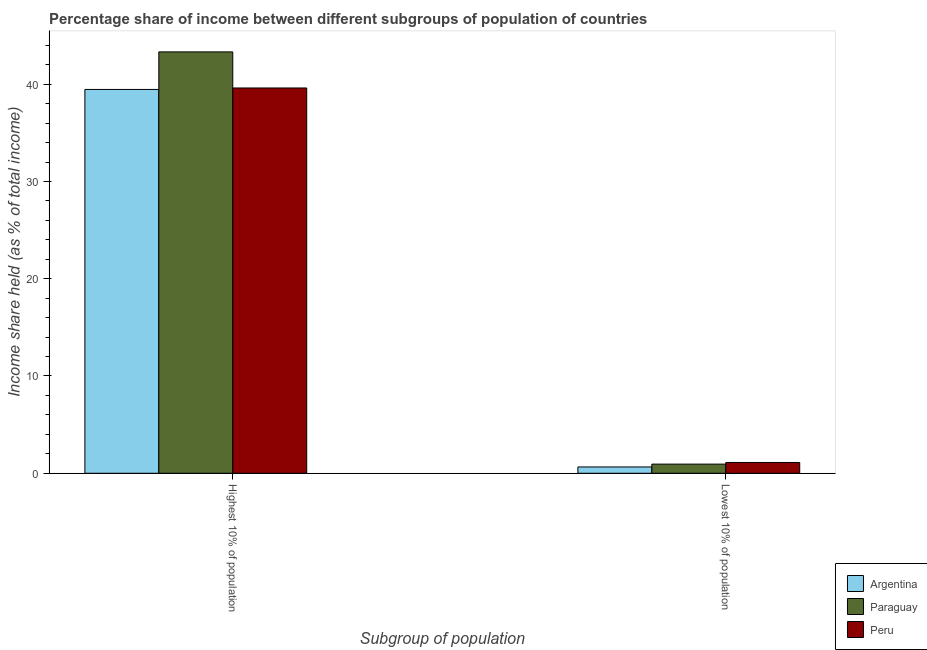How many different coloured bars are there?
Offer a very short reply. 3. How many bars are there on the 2nd tick from the left?
Your response must be concise. 3. How many bars are there on the 2nd tick from the right?
Ensure brevity in your answer.  3. What is the label of the 2nd group of bars from the left?
Provide a short and direct response. Lowest 10% of population. What is the income share held by highest 10% of the population in Argentina?
Your answer should be very brief. 39.46. Across all countries, what is the maximum income share held by highest 10% of the population?
Your answer should be very brief. 43.32. Across all countries, what is the minimum income share held by lowest 10% of the population?
Keep it short and to the point. 0.65. In which country was the income share held by highest 10% of the population minimum?
Ensure brevity in your answer.  Argentina. What is the total income share held by highest 10% of the population in the graph?
Make the answer very short. 122.39. What is the difference between the income share held by lowest 10% of the population in Peru and that in Argentina?
Give a very brief answer. 0.46. What is the difference between the income share held by lowest 10% of the population in Peru and the income share held by highest 10% of the population in Argentina?
Offer a very short reply. -38.35. What is the average income share held by highest 10% of the population per country?
Your answer should be compact. 40.8. What is the difference between the income share held by lowest 10% of the population and income share held by highest 10% of the population in Argentina?
Your response must be concise. -38.81. What is the ratio of the income share held by lowest 10% of the population in Paraguay to that in Argentina?
Offer a very short reply. 1.45. Is the income share held by lowest 10% of the population in Peru less than that in Paraguay?
Your response must be concise. No. What does the 2nd bar from the left in Highest 10% of population represents?
Give a very brief answer. Paraguay. How many countries are there in the graph?
Offer a terse response. 3. Does the graph contain any zero values?
Provide a short and direct response. No. Where does the legend appear in the graph?
Give a very brief answer. Bottom right. What is the title of the graph?
Your answer should be very brief. Percentage share of income between different subgroups of population of countries. Does "Arab World" appear as one of the legend labels in the graph?
Make the answer very short. No. What is the label or title of the X-axis?
Your response must be concise. Subgroup of population. What is the label or title of the Y-axis?
Your answer should be compact. Income share held (as % of total income). What is the Income share held (as % of total income) of Argentina in Highest 10% of population?
Ensure brevity in your answer.  39.46. What is the Income share held (as % of total income) in Paraguay in Highest 10% of population?
Your response must be concise. 43.32. What is the Income share held (as % of total income) of Peru in Highest 10% of population?
Your answer should be very brief. 39.61. What is the Income share held (as % of total income) in Argentina in Lowest 10% of population?
Make the answer very short. 0.65. What is the Income share held (as % of total income) of Paraguay in Lowest 10% of population?
Offer a terse response. 0.94. What is the Income share held (as % of total income) in Peru in Lowest 10% of population?
Your answer should be compact. 1.11. Across all Subgroup of population, what is the maximum Income share held (as % of total income) of Argentina?
Provide a short and direct response. 39.46. Across all Subgroup of population, what is the maximum Income share held (as % of total income) of Paraguay?
Ensure brevity in your answer.  43.32. Across all Subgroup of population, what is the maximum Income share held (as % of total income) of Peru?
Offer a very short reply. 39.61. Across all Subgroup of population, what is the minimum Income share held (as % of total income) in Argentina?
Offer a terse response. 0.65. Across all Subgroup of population, what is the minimum Income share held (as % of total income) in Paraguay?
Provide a short and direct response. 0.94. Across all Subgroup of population, what is the minimum Income share held (as % of total income) in Peru?
Keep it short and to the point. 1.11. What is the total Income share held (as % of total income) of Argentina in the graph?
Make the answer very short. 40.11. What is the total Income share held (as % of total income) in Paraguay in the graph?
Provide a succinct answer. 44.26. What is the total Income share held (as % of total income) of Peru in the graph?
Give a very brief answer. 40.72. What is the difference between the Income share held (as % of total income) in Argentina in Highest 10% of population and that in Lowest 10% of population?
Offer a terse response. 38.81. What is the difference between the Income share held (as % of total income) in Paraguay in Highest 10% of population and that in Lowest 10% of population?
Ensure brevity in your answer.  42.38. What is the difference between the Income share held (as % of total income) in Peru in Highest 10% of population and that in Lowest 10% of population?
Give a very brief answer. 38.5. What is the difference between the Income share held (as % of total income) in Argentina in Highest 10% of population and the Income share held (as % of total income) in Paraguay in Lowest 10% of population?
Your answer should be compact. 38.52. What is the difference between the Income share held (as % of total income) in Argentina in Highest 10% of population and the Income share held (as % of total income) in Peru in Lowest 10% of population?
Offer a very short reply. 38.35. What is the difference between the Income share held (as % of total income) of Paraguay in Highest 10% of population and the Income share held (as % of total income) of Peru in Lowest 10% of population?
Your answer should be very brief. 42.21. What is the average Income share held (as % of total income) of Argentina per Subgroup of population?
Your answer should be compact. 20.05. What is the average Income share held (as % of total income) in Paraguay per Subgroup of population?
Give a very brief answer. 22.13. What is the average Income share held (as % of total income) in Peru per Subgroup of population?
Your answer should be very brief. 20.36. What is the difference between the Income share held (as % of total income) in Argentina and Income share held (as % of total income) in Paraguay in Highest 10% of population?
Ensure brevity in your answer.  -3.86. What is the difference between the Income share held (as % of total income) in Argentina and Income share held (as % of total income) in Peru in Highest 10% of population?
Ensure brevity in your answer.  -0.15. What is the difference between the Income share held (as % of total income) of Paraguay and Income share held (as % of total income) of Peru in Highest 10% of population?
Ensure brevity in your answer.  3.71. What is the difference between the Income share held (as % of total income) in Argentina and Income share held (as % of total income) in Paraguay in Lowest 10% of population?
Offer a terse response. -0.29. What is the difference between the Income share held (as % of total income) in Argentina and Income share held (as % of total income) in Peru in Lowest 10% of population?
Your answer should be very brief. -0.46. What is the difference between the Income share held (as % of total income) in Paraguay and Income share held (as % of total income) in Peru in Lowest 10% of population?
Give a very brief answer. -0.17. What is the ratio of the Income share held (as % of total income) in Argentina in Highest 10% of population to that in Lowest 10% of population?
Your answer should be very brief. 60.71. What is the ratio of the Income share held (as % of total income) in Paraguay in Highest 10% of population to that in Lowest 10% of population?
Your answer should be compact. 46.09. What is the ratio of the Income share held (as % of total income) in Peru in Highest 10% of population to that in Lowest 10% of population?
Make the answer very short. 35.68. What is the difference between the highest and the second highest Income share held (as % of total income) in Argentina?
Your answer should be compact. 38.81. What is the difference between the highest and the second highest Income share held (as % of total income) of Paraguay?
Your response must be concise. 42.38. What is the difference between the highest and the second highest Income share held (as % of total income) of Peru?
Provide a short and direct response. 38.5. What is the difference between the highest and the lowest Income share held (as % of total income) in Argentina?
Your answer should be very brief. 38.81. What is the difference between the highest and the lowest Income share held (as % of total income) in Paraguay?
Ensure brevity in your answer.  42.38. What is the difference between the highest and the lowest Income share held (as % of total income) in Peru?
Keep it short and to the point. 38.5. 